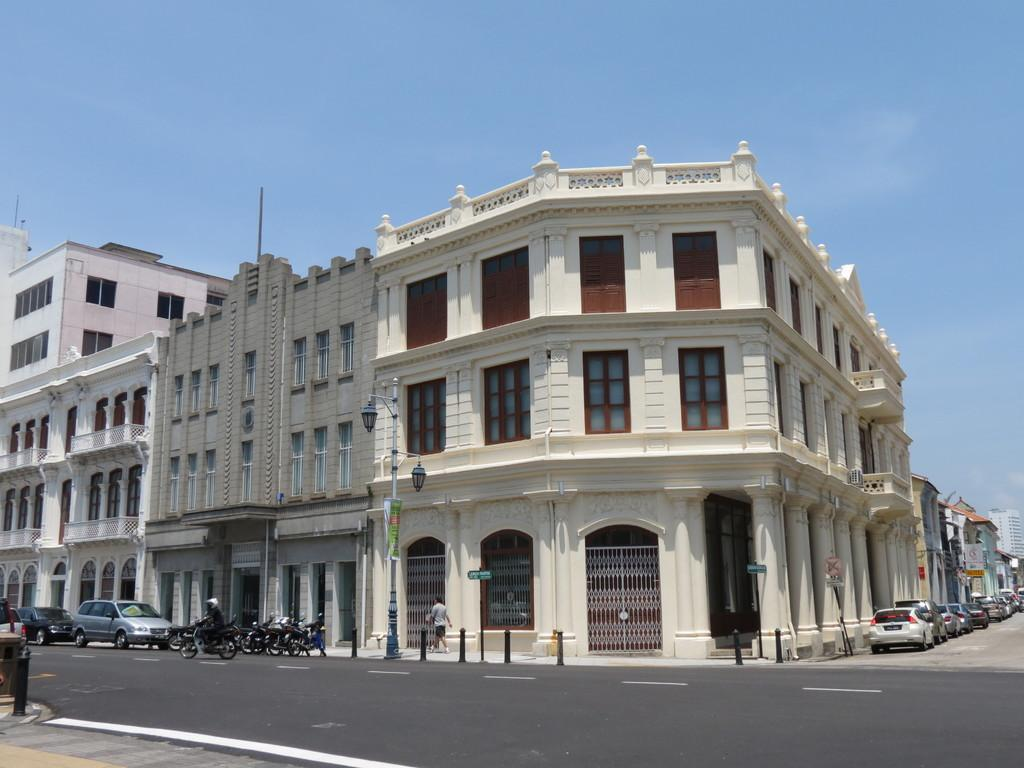What is located in the center of the image? There are buildings in the center of the image. What types of vehicles can be seen at the bottom of the image? Cars and bikes are visible at the bottom of the image. Can you describe the person in the image? There is a man walking in the image. What is the tall, vertical object in the image? A pole is present in the image. What is visible at the top of the image? The sky is visible at the top of the image. What type of trade is happening between the buildings in the image? There is no indication of any trade happening between the buildings in the image. Can you describe the man's lips in the image? There is no specific detail about the man's lips in the image. 